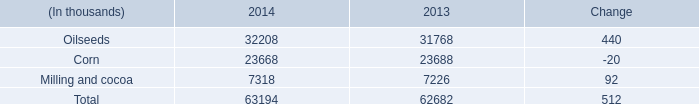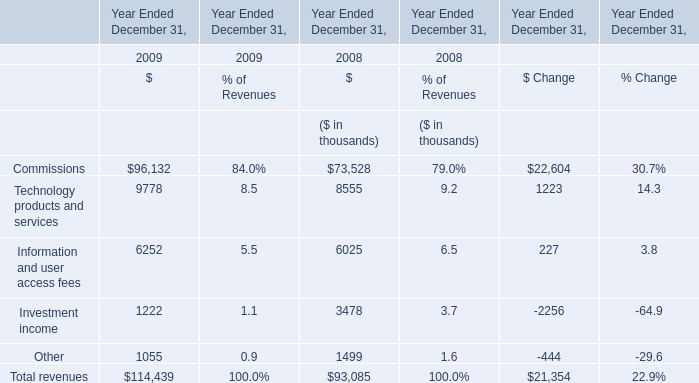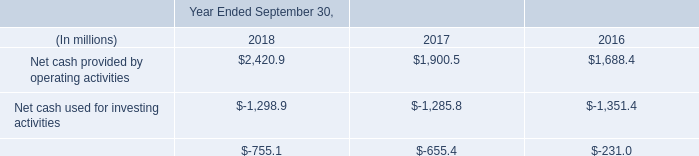Which year is the percentage of Investment income in relation to Revenues lower? 
Answer: 2009. What is the value of the Total revenues in 2008, excluding the Investment income in 2008 and the Information and user access fees in 2008? (in thousand) 
Computations: ((93085 - 3478) - 6025)
Answer: 83582.0. 